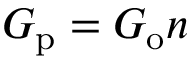Convert formula to latex. <formula><loc_0><loc_0><loc_500><loc_500>G _ { p } = G _ { o } n</formula> 